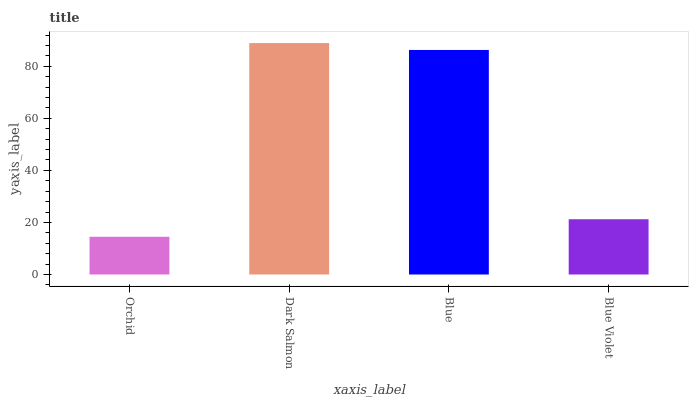Is Orchid the minimum?
Answer yes or no. Yes. Is Dark Salmon the maximum?
Answer yes or no. Yes. Is Blue the minimum?
Answer yes or no. No. Is Blue the maximum?
Answer yes or no. No. Is Dark Salmon greater than Blue?
Answer yes or no. Yes. Is Blue less than Dark Salmon?
Answer yes or no. Yes. Is Blue greater than Dark Salmon?
Answer yes or no. No. Is Dark Salmon less than Blue?
Answer yes or no. No. Is Blue the high median?
Answer yes or no. Yes. Is Blue Violet the low median?
Answer yes or no. Yes. Is Blue Violet the high median?
Answer yes or no. No. Is Blue the low median?
Answer yes or no. No. 